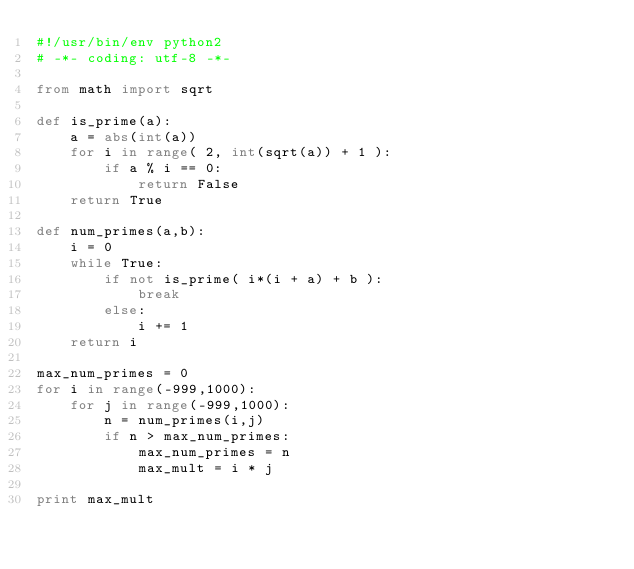Convert code to text. <code><loc_0><loc_0><loc_500><loc_500><_Python_>#!/usr/bin/env python2
# -*- coding: utf-8 -*-

from math import sqrt

def is_prime(a):
    a = abs(int(a))
    for i in range( 2, int(sqrt(a)) + 1 ):
        if a % i == 0:
            return False
    return True

def num_primes(a,b):
    i = 0
    while True:
        if not is_prime( i*(i + a) + b ):
            break
        else:
            i += 1
    return i

max_num_primes = 0
for i in range(-999,1000):
    for j in range(-999,1000):
        n = num_primes(i,j)
        if n > max_num_primes:
            max_num_primes = n
            max_mult = i * j

print max_mult</code> 